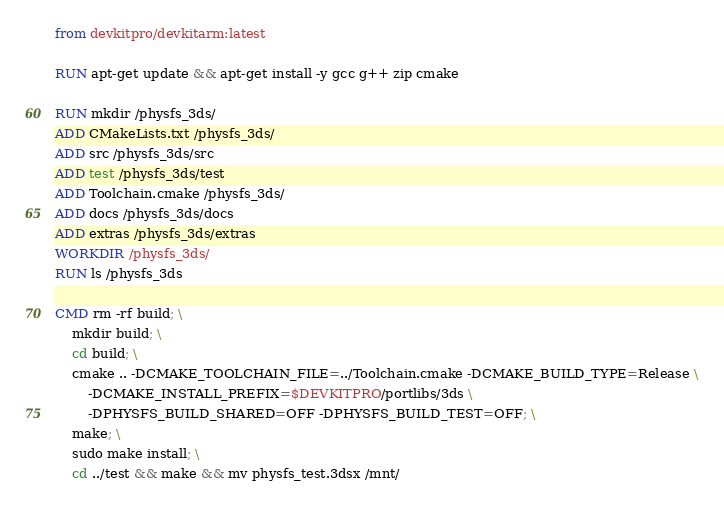<code> <loc_0><loc_0><loc_500><loc_500><_Dockerfile_>from devkitpro/devkitarm:latest

RUN apt-get update && apt-get install -y gcc g++ zip cmake

RUN mkdir /physfs_3ds/
ADD CMakeLists.txt /physfs_3ds/
ADD src /physfs_3ds/src
ADD test /physfs_3ds/test
ADD Toolchain.cmake /physfs_3ds/
ADD docs /physfs_3ds/docs
ADD extras /physfs_3ds/extras
WORKDIR /physfs_3ds/
RUN ls /physfs_3ds

CMD rm -rf build; \
    mkdir build; \
    cd build; \
    cmake .. -DCMAKE_TOOLCHAIN_FILE=../Toolchain.cmake -DCMAKE_BUILD_TYPE=Release \
        -DCMAKE_INSTALL_PREFIX=$DEVKITPRO/portlibs/3ds \
        -DPHYSFS_BUILD_SHARED=OFF -DPHYSFS_BUILD_TEST=OFF; \
    make; \
    sudo make install; \
    cd ../test && make && mv physfs_test.3dsx /mnt/
</code> 